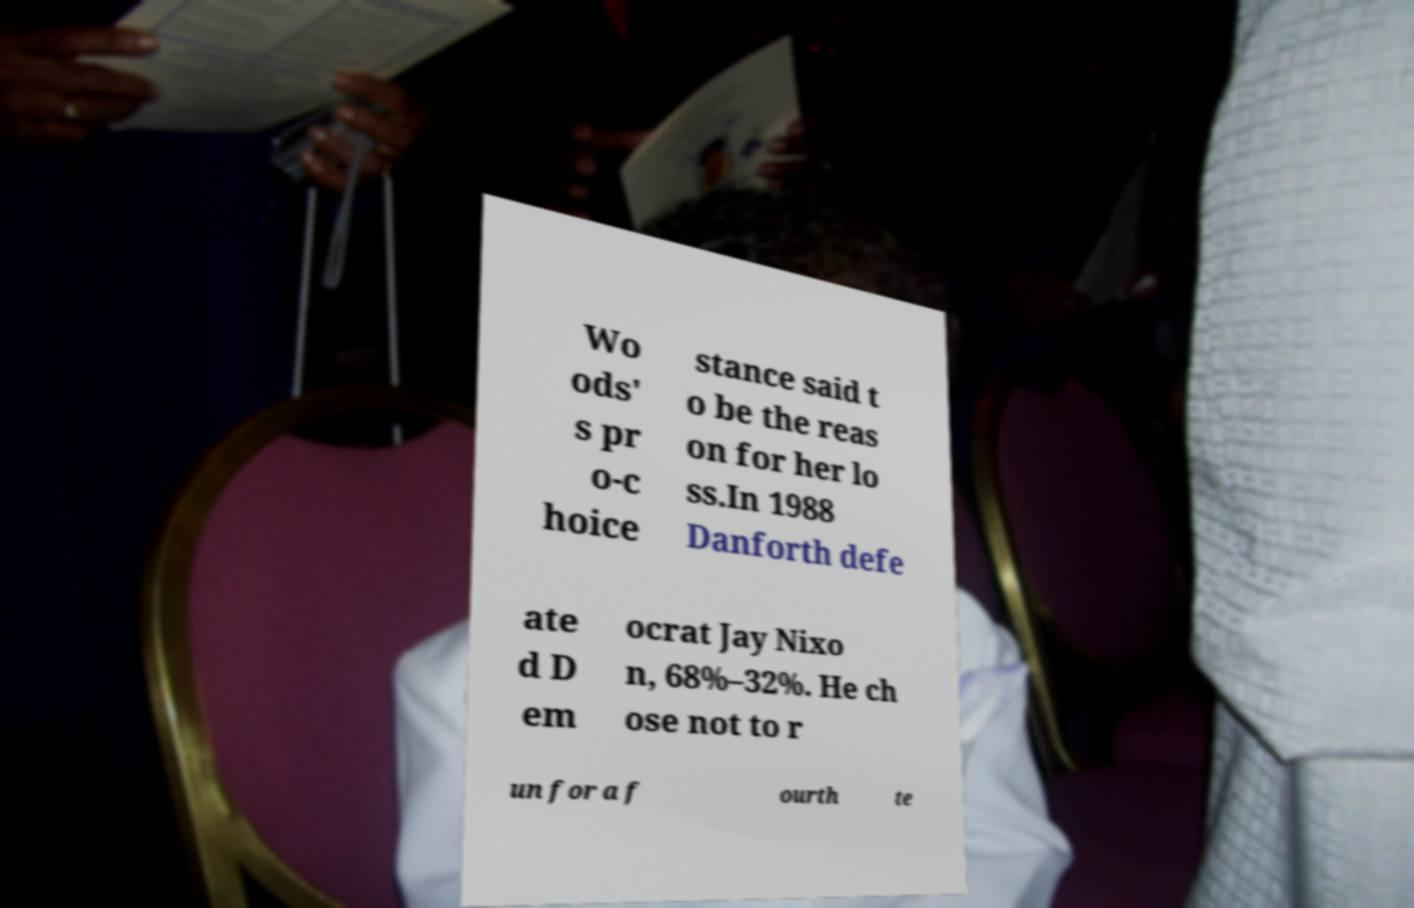Could you assist in decoding the text presented in this image and type it out clearly? Wo ods' s pr o-c hoice stance said t o be the reas on for her lo ss.In 1988 Danforth defe ate d D em ocrat Jay Nixo n, 68%–32%. He ch ose not to r un for a f ourth te 